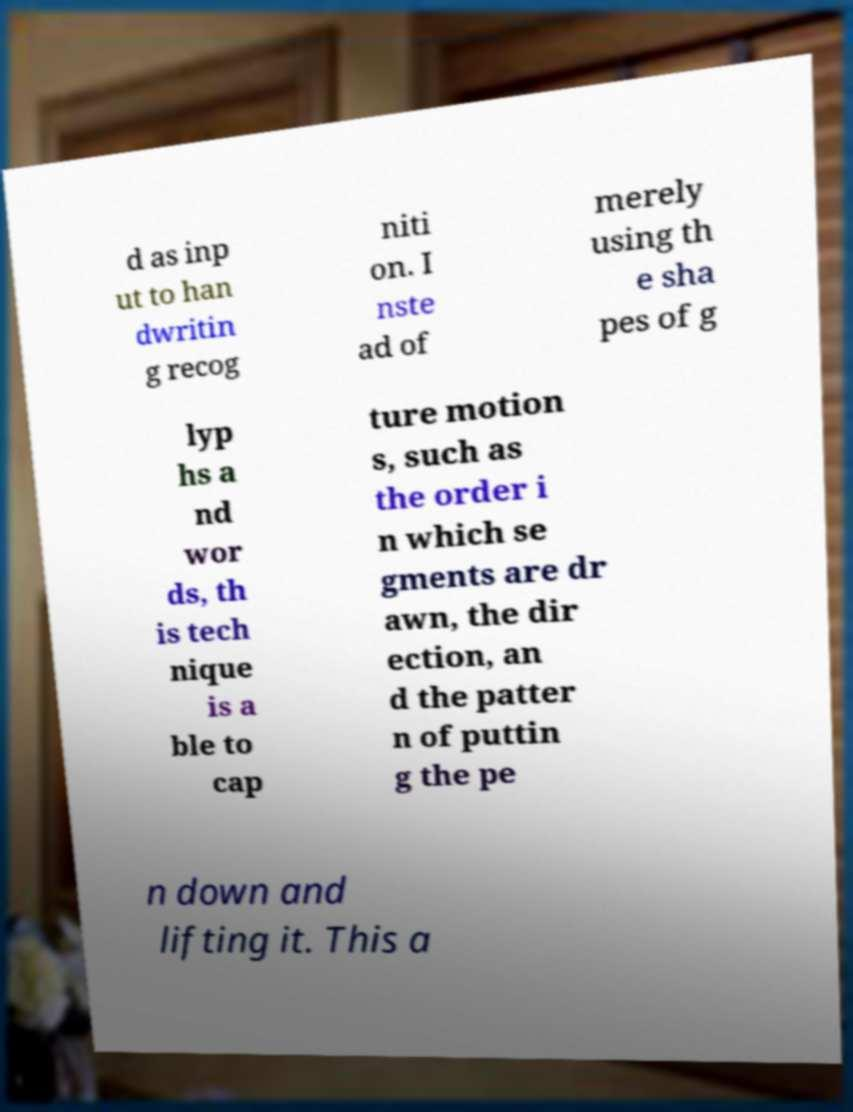Can you accurately transcribe the text from the provided image for me? d as inp ut to han dwritin g recog niti on. I nste ad of merely using th e sha pes of g lyp hs a nd wor ds, th is tech nique is a ble to cap ture motion s, such as the order i n which se gments are dr awn, the dir ection, an d the patter n of puttin g the pe n down and lifting it. This a 